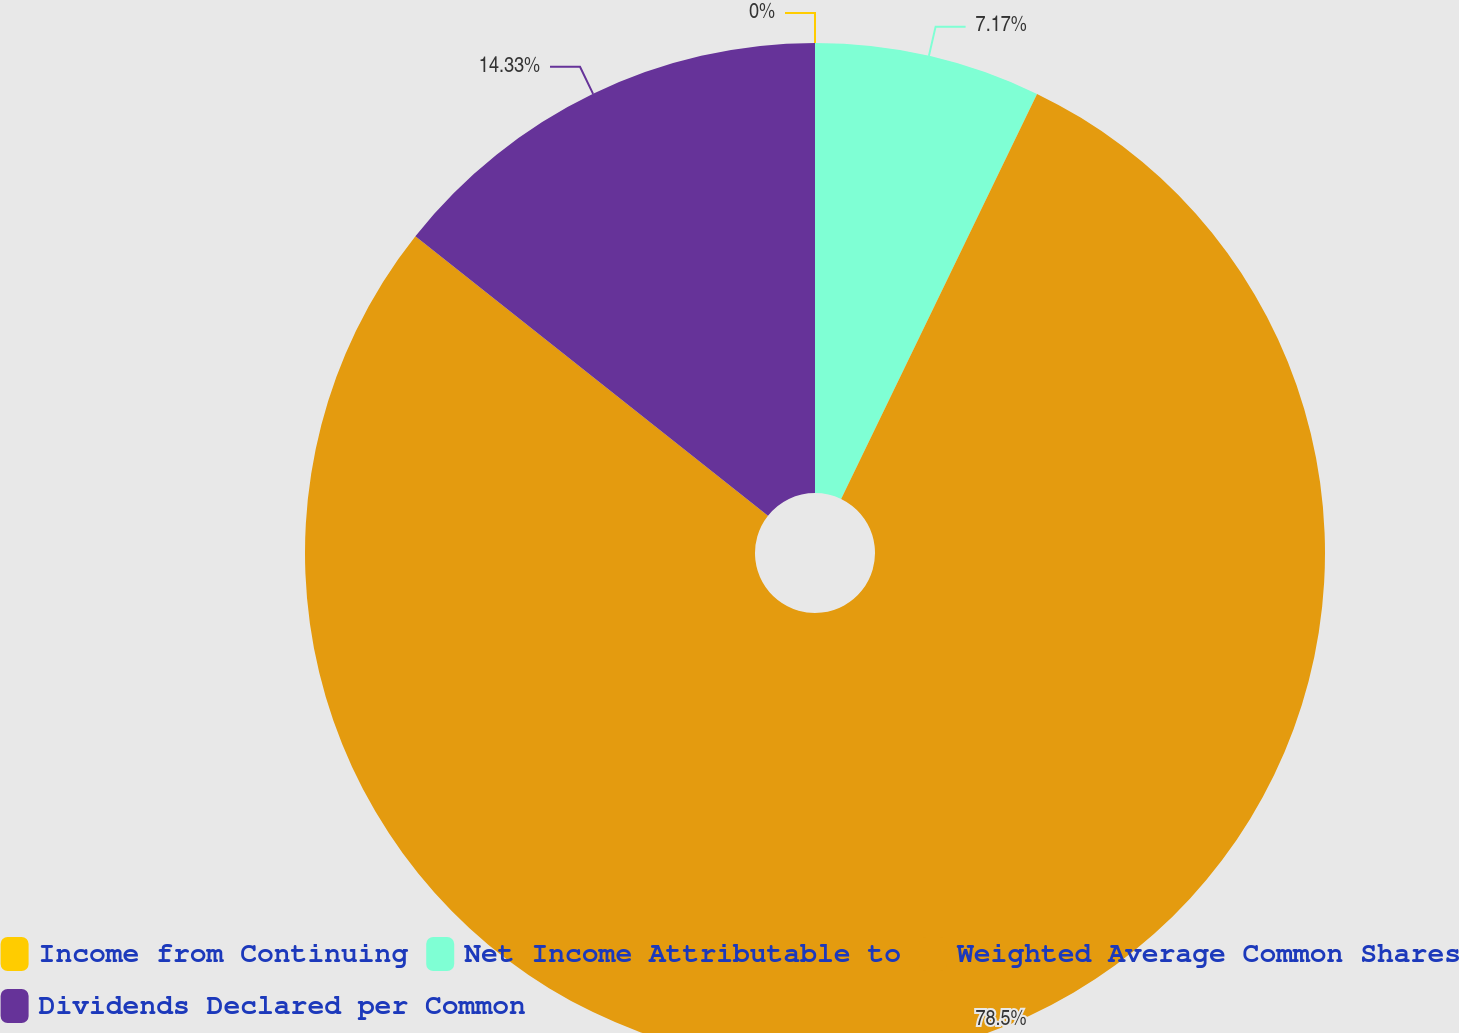<chart> <loc_0><loc_0><loc_500><loc_500><pie_chart><fcel>Income from Continuing<fcel>Net Income Attributable to<fcel>Weighted Average Common Shares<fcel>Dividends Declared per Common<nl><fcel>0.0%<fcel>7.17%<fcel>78.5%<fcel>14.33%<nl></chart> 